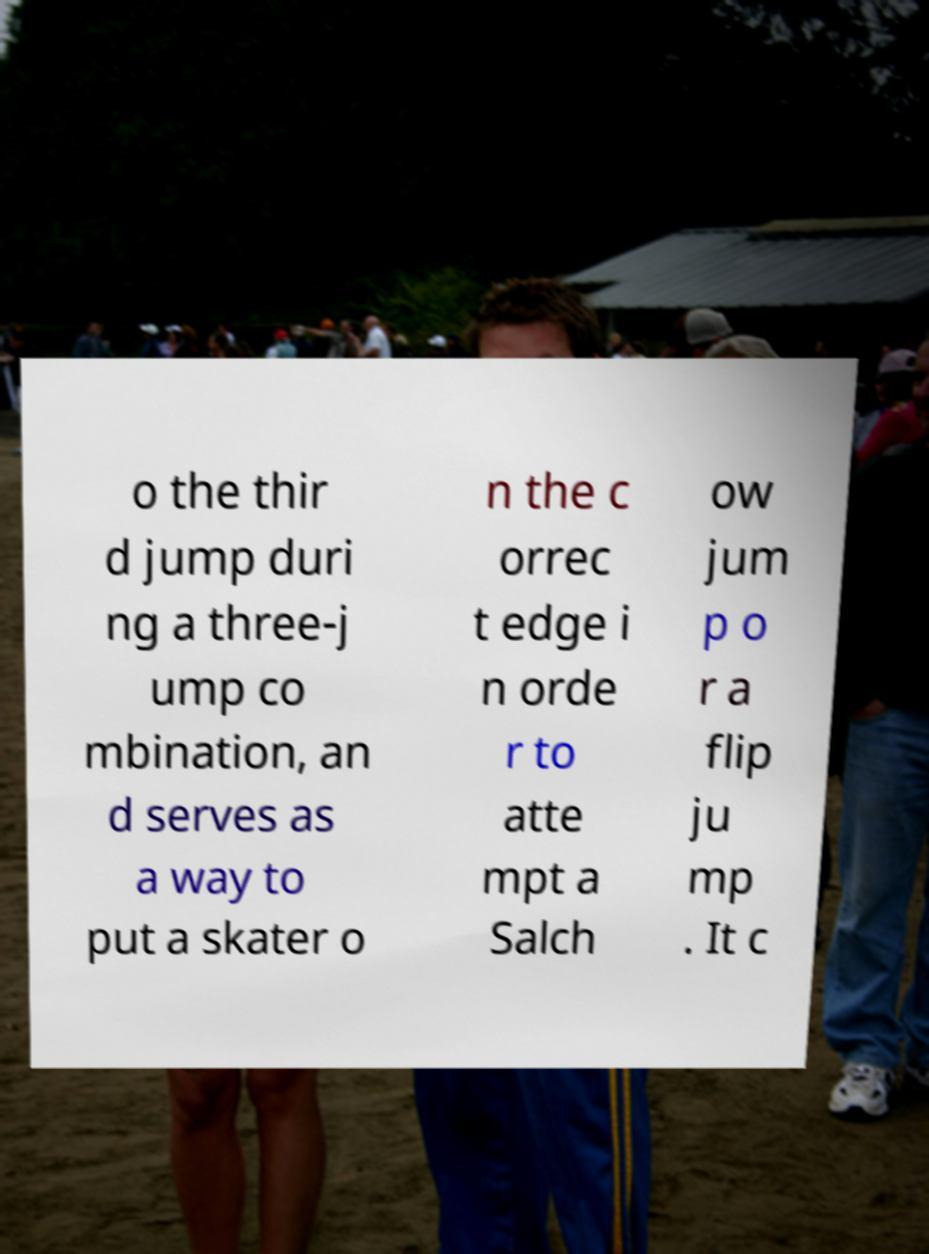I need the written content from this picture converted into text. Can you do that? o the thir d jump duri ng a three-j ump co mbination, an d serves as a way to put a skater o n the c orrec t edge i n orde r to atte mpt a Salch ow jum p o r a flip ju mp . It c 